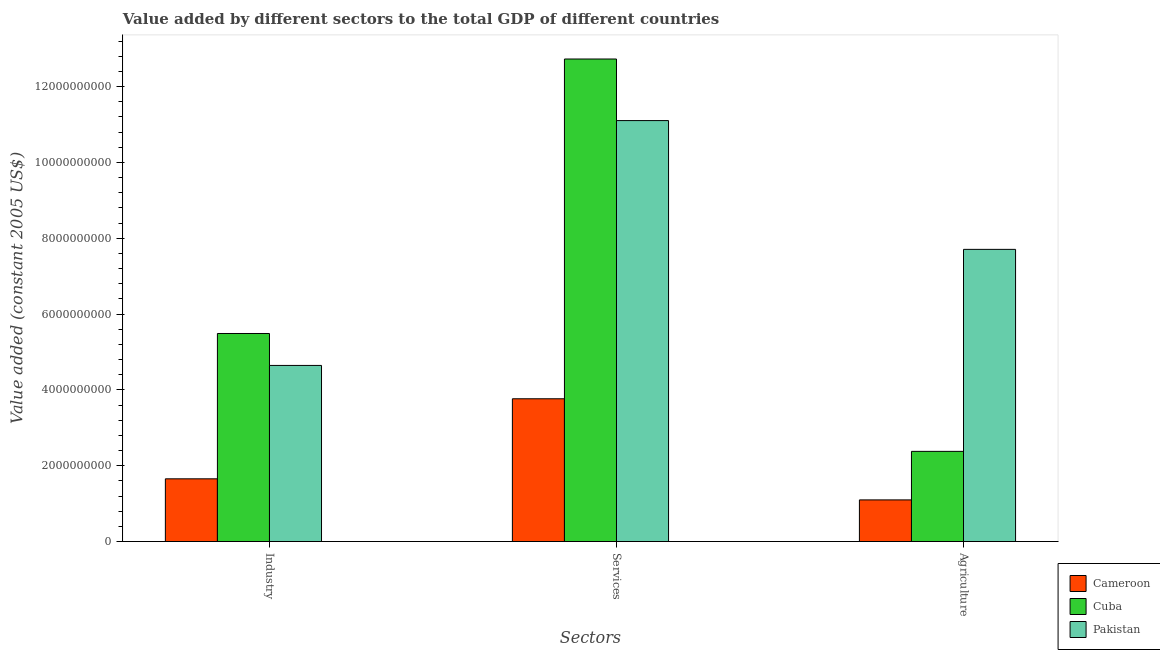How many different coloured bars are there?
Make the answer very short. 3. Are the number of bars on each tick of the X-axis equal?
Give a very brief answer. Yes. How many bars are there on the 2nd tick from the left?
Your response must be concise. 3. What is the label of the 2nd group of bars from the left?
Your response must be concise. Services. What is the value added by agricultural sector in Cuba?
Ensure brevity in your answer.  2.38e+09. Across all countries, what is the maximum value added by agricultural sector?
Provide a short and direct response. 7.71e+09. Across all countries, what is the minimum value added by industrial sector?
Your response must be concise. 1.65e+09. In which country was the value added by agricultural sector maximum?
Provide a short and direct response. Pakistan. In which country was the value added by agricultural sector minimum?
Your answer should be compact. Cameroon. What is the total value added by agricultural sector in the graph?
Offer a very short reply. 1.12e+1. What is the difference between the value added by agricultural sector in Cuba and that in Pakistan?
Give a very brief answer. -5.33e+09. What is the difference between the value added by industrial sector in Pakistan and the value added by agricultural sector in Cuba?
Provide a succinct answer. 2.27e+09. What is the average value added by services per country?
Give a very brief answer. 9.20e+09. What is the difference between the value added by industrial sector and value added by agricultural sector in Pakistan?
Provide a short and direct response. -3.06e+09. In how many countries, is the value added by services greater than 6800000000 US$?
Provide a succinct answer. 2. What is the ratio of the value added by agricultural sector in Pakistan to that in Cameroon?
Ensure brevity in your answer.  7.01. Is the difference between the value added by services in Pakistan and Cameroon greater than the difference between the value added by industrial sector in Pakistan and Cameroon?
Offer a terse response. Yes. What is the difference between the highest and the second highest value added by services?
Provide a short and direct response. 1.62e+09. What is the difference between the highest and the lowest value added by agricultural sector?
Keep it short and to the point. 6.61e+09. Is the sum of the value added by services in Pakistan and Cameroon greater than the maximum value added by agricultural sector across all countries?
Provide a succinct answer. Yes. What does the 1st bar from the left in Industry represents?
Keep it short and to the point. Cameroon. What does the 3rd bar from the right in Services represents?
Offer a terse response. Cameroon. Is it the case that in every country, the sum of the value added by industrial sector and value added by services is greater than the value added by agricultural sector?
Offer a very short reply. Yes. How many bars are there?
Offer a terse response. 9. Are all the bars in the graph horizontal?
Your answer should be very brief. No. What is the difference between two consecutive major ticks on the Y-axis?
Offer a terse response. 2.00e+09. Are the values on the major ticks of Y-axis written in scientific E-notation?
Your answer should be compact. No. What is the title of the graph?
Offer a terse response. Value added by different sectors to the total GDP of different countries. Does "Cuba" appear as one of the legend labels in the graph?
Offer a very short reply. Yes. What is the label or title of the X-axis?
Make the answer very short. Sectors. What is the label or title of the Y-axis?
Offer a terse response. Value added (constant 2005 US$). What is the Value added (constant 2005 US$) in Cameroon in Industry?
Give a very brief answer. 1.65e+09. What is the Value added (constant 2005 US$) in Cuba in Industry?
Keep it short and to the point. 5.49e+09. What is the Value added (constant 2005 US$) of Pakistan in Industry?
Make the answer very short. 4.64e+09. What is the Value added (constant 2005 US$) in Cameroon in Services?
Your response must be concise. 3.77e+09. What is the Value added (constant 2005 US$) of Cuba in Services?
Provide a short and direct response. 1.27e+1. What is the Value added (constant 2005 US$) in Pakistan in Services?
Your answer should be very brief. 1.11e+1. What is the Value added (constant 2005 US$) of Cameroon in Agriculture?
Ensure brevity in your answer.  1.10e+09. What is the Value added (constant 2005 US$) of Cuba in Agriculture?
Your answer should be compact. 2.38e+09. What is the Value added (constant 2005 US$) of Pakistan in Agriculture?
Make the answer very short. 7.71e+09. Across all Sectors, what is the maximum Value added (constant 2005 US$) in Cameroon?
Your answer should be compact. 3.77e+09. Across all Sectors, what is the maximum Value added (constant 2005 US$) of Cuba?
Provide a succinct answer. 1.27e+1. Across all Sectors, what is the maximum Value added (constant 2005 US$) in Pakistan?
Make the answer very short. 1.11e+1. Across all Sectors, what is the minimum Value added (constant 2005 US$) in Cameroon?
Your answer should be very brief. 1.10e+09. Across all Sectors, what is the minimum Value added (constant 2005 US$) in Cuba?
Offer a terse response. 2.38e+09. Across all Sectors, what is the minimum Value added (constant 2005 US$) in Pakistan?
Offer a very short reply. 4.64e+09. What is the total Value added (constant 2005 US$) of Cameroon in the graph?
Ensure brevity in your answer.  6.52e+09. What is the total Value added (constant 2005 US$) in Cuba in the graph?
Give a very brief answer. 2.06e+1. What is the total Value added (constant 2005 US$) of Pakistan in the graph?
Provide a succinct answer. 2.35e+1. What is the difference between the Value added (constant 2005 US$) of Cameroon in Industry and that in Services?
Your answer should be compact. -2.11e+09. What is the difference between the Value added (constant 2005 US$) of Cuba in Industry and that in Services?
Keep it short and to the point. -7.24e+09. What is the difference between the Value added (constant 2005 US$) of Pakistan in Industry and that in Services?
Your response must be concise. -6.46e+09. What is the difference between the Value added (constant 2005 US$) of Cameroon in Industry and that in Agriculture?
Offer a terse response. 5.56e+08. What is the difference between the Value added (constant 2005 US$) of Cuba in Industry and that in Agriculture?
Keep it short and to the point. 3.11e+09. What is the difference between the Value added (constant 2005 US$) of Pakistan in Industry and that in Agriculture?
Provide a short and direct response. -3.06e+09. What is the difference between the Value added (constant 2005 US$) of Cameroon in Services and that in Agriculture?
Give a very brief answer. 2.67e+09. What is the difference between the Value added (constant 2005 US$) of Cuba in Services and that in Agriculture?
Keep it short and to the point. 1.03e+1. What is the difference between the Value added (constant 2005 US$) of Pakistan in Services and that in Agriculture?
Provide a short and direct response. 3.40e+09. What is the difference between the Value added (constant 2005 US$) in Cameroon in Industry and the Value added (constant 2005 US$) in Cuba in Services?
Your response must be concise. -1.11e+1. What is the difference between the Value added (constant 2005 US$) of Cameroon in Industry and the Value added (constant 2005 US$) of Pakistan in Services?
Provide a short and direct response. -9.45e+09. What is the difference between the Value added (constant 2005 US$) in Cuba in Industry and the Value added (constant 2005 US$) in Pakistan in Services?
Your answer should be very brief. -5.61e+09. What is the difference between the Value added (constant 2005 US$) in Cameroon in Industry and the Value added (constant 2005 US$) in Cuba in Agriculture?
Offer a very short reply. -7.24e+08. What is the difference between the Value added (constant 2005 US$) of Cameroon in Industry and the Value added (constant 2005 US$) of Pakistan in Agriculture?
Provide a succinct answer. -6.05e+09. What is the difference between the Value added (constant 2005 US$) of Cuba in Industry and the Value added (constant 2005 US$) of Pakistan in Agriculture?
Keep it short and to the point. -2.22e+09. What is the difference between the Value added (constant 2005 US$) of Cameroon in Services and the Value added (constant 2005 US$) of Cuba in Agriculture?
Your answer should be compact. 1.39e+09. What is the difference between the Value added (constant 2005 US$) in Cameroon in Services and the Value added (constant 2005 US$) in Pakistan in Agriculture?
Your response must be concise. -3.94e+09. What is the difference between the Value added (constant 2005 US$) of Cuba in Services and the Value added (constant 2005 US$) of Pakistan in Agriculture?
Ensure brevity in your answer.  5.02e+09. What is the average Value added (constant 2005 US$) in Cameroon per Sectors?
Your response must be concise. 2.17e+09. What is the average Value added (constant 2005 US$) of Cuba per Sectors?
Your response must be concise. 6.86e+09. What is the average Value added (constant 2005 US$) of Pakistan per Sectors?
Your answer should be very brief. 7.82e+09. What is the difference between the Value added (constant 2005 US$) in Cameroon and Value added (constant 2005 US$) in Cuba in Industry?
Give a very brief answer. -3.83e+09. What is the difference between the Value added (constant 2005 US$) of Cameroon and Value added (constant 2005 US$) of Pakistan in Industry?
Provide a succinct answer. -2.99e+09. What is the difference between the Value added (constant 2005 US$) of Cuba and Value added (constant 2005 US$) of Pakistan in Industry?
Provide a short and direct response. 8.42e+08. What is the difference between the Value added (constant 2005 US$) of Cameroon and Value added (constant 2005 US$) of Cuba in Services?
Provide a short and direct response. -8.96e+09. What is the difference between the Value added (constant 2005 US$) of Cameroon and Value added (constant 2005 US$) of Pakistan in Services?
Ensure brevity in your answer.  -7.34e+09. What is the difference between the Value added (constant 2005 US$) of Cuba and Value added (constant 2005 US$) of Pakistan in Services?
Offer a very short reply. 1.62e+09. What is the difference between the Value added (constant 2005 US$) of Cameroon and Value added (constant 2005 US$) of Cuba in Agriculture?
Your answer should be compact. -1.28e+09. What is the difference between the Value added (constant 2005 US$) in Cameroon and Value added (constant 2005 US$) in Pakistan in Agriculture?
Provide a short and direct response. -6.61e+09. What is the difference between the Value added (constant 2005 US$) in Cuba and Value added (constant 2005 US$) in Pakistan in Agriculture?
Give a very brief answer. -5.33e+09. What is the ratio of the Value added (constant 2005 US$) of Cameroon in Industry to that in Services?
Give a very brief answer. 0.44. What is the ratio of the Value added (constant 2005 US$) in Cuba in Industry to that in Services?
Your answer should be very brief. 0.43. What is the ratio of the Value added (constant 2005 US$) in Pakistan in Industry to that in Services?
Ensure brevity in your answer.  0.42. What is the ratio of the Value added (constant 2005 US$) in Cameroon in Industry to that in Agriculture?
Ensure brevity in your answer.  1.51. What is the ratio of the Value added (constant 2005 US$) of Cuba in Industry to that in Agriculture?
Offer a very short reply. 2.31. What is the ratio of the Value added (constant 2005 US$) in Pakistan in Industry to that in Agriculture?
Your answer should be very brief. 0.6. What is the ratio of the Value added (constant 2005 US$) of Cameroon in Services to that in Agriculture?
Ensure brevity in your answer.  3.43. What is the ratio of the Value added (constant 2005 US$) in Cuba in Services to that in Agriculture?
Your response must be concise. 5.35. What is the ratio of the Value added (constant 2005 US$) of Pakistan in Services to that in Agriculture?
Give a very brief answer. 1.44. What is the difference between the highest and the second highest Value added (constant 2005 US$) of Cameroon?
Keep it short and to the point. 2.11e+09. What is the difference between the highest and the second highest Value added (constant 2005 US$) of Cuba?
Provide a succinct answer. 7.24e+09. What is the difference between the highest and the second highest Value added (constant 2005 US$) of Pakistan?
Ensure brevity in your answer.  3.40e+09. What is the difference between the highest and the lowest Value added (constant 2005 US$) in Cameroon?
Offer a very short reply. 2.67e+09. What is the difference between the highest and the lowest Value added (constant 2005 US$) of Cuba?
Ensure brevity in your answer.  1.03e+1. What is the difference between the highest and the lowest Value added (constant 2005 US$) in Pakistan?
Ensure brevity in your answer.  6.46e+09. 